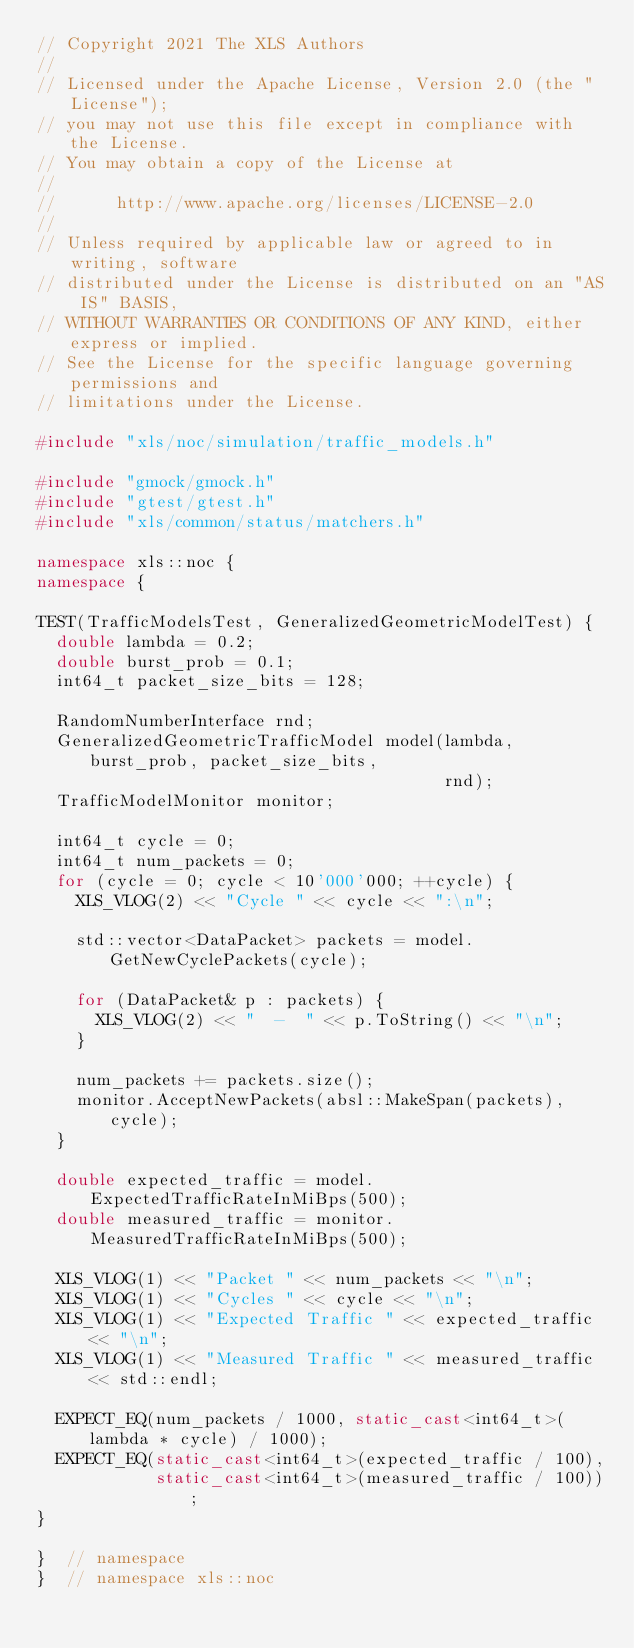<code> <loc_0><loc_0><loc_500><loc_500><_C++_>// Copyright 2021 The XLS Authors
//
// Licensed under the Apache License, Version 2.0 (the "License");
// you may not use this file except in compliance with the License.
// You may obtain a copy of the License at
//
//      http://www.apache.org/licenses/LICENSE-2.0
//
// Unless required by applicable law or agreed to in writing, software
// distributed under the License is distributed on an "AS IS" BASIS,
// WITHOUT WARRANTIES OR CONDITIONS OF ANY KIND, either express or implied.
// See the License for the specific language governing permissions and
// limitations under the License.

#include "xls/noc/simulation/traffic_models.h"

#include "gmock/gmock.h"
#include "gtest/gtest.h"
#include "xls/common/status/matchers.h"

namespace xls::noc {
namespace {

TEST(TrafficModelsTest, GeneralizedGeometricModelTest) {
  double lambda = 0.2;
  double burst_prob = 0.1;
  int64_t packet_size_bits = 128;

  RandomNumberInterface rnd;
  GeneralizedGeometricTrafficModel model(lambda, burst_prob, packet_size_bits,
                                         rnd);
  TrafficModelMonitor monitor;

  int64_t cycle = 0;
  int64_t num_packets = 0;
  for (cycle = 0; cycle < 10'000'000; ++cycle) {
    XLS_VLOG(2) << "Cycle " << cycle << ":\n";

    std::vector<DataPacket> packets = model.GetNewCyclePackets(cycle);

    for (DataPacket& p : packets) {
      XLS_VLOG(2) << "  -  " << p.ToString() << "\n";
    }

    num_packets += packets.size();
    monitor.AcceptNewPackets(absl::MakeSpan(packets), cycle);
  }

  double expected_traffic = model.ExpectedTrafficRateInMiBps(500);
  double measured_traffic = monitor.MeasuredTrafficRateInMiBps(500);

  XLS_VLOG(1) << "Packet " << num_packets << "\n";
  XLS_VLOG(1) << "Cycles " << cycle << "\n";
  XLS_VLOG(1) << "Expected Traffic " << expected_traffic << "\n";
  XLS_VLOG(1) << "Measured Traffic " << measured_traffic << std::endl;

  EXPECT_EQ(num_packets / 1000, static_cast<int64_t>(lambda * cycle) / 1000);
  EXPECT_EQ(static_cast<int64_t>(expected_traffic / 100),
            static_cast<int64_t>(measured_traffic / 100));
}

}  // namespace
}  // namespace xls::noc
</code> 